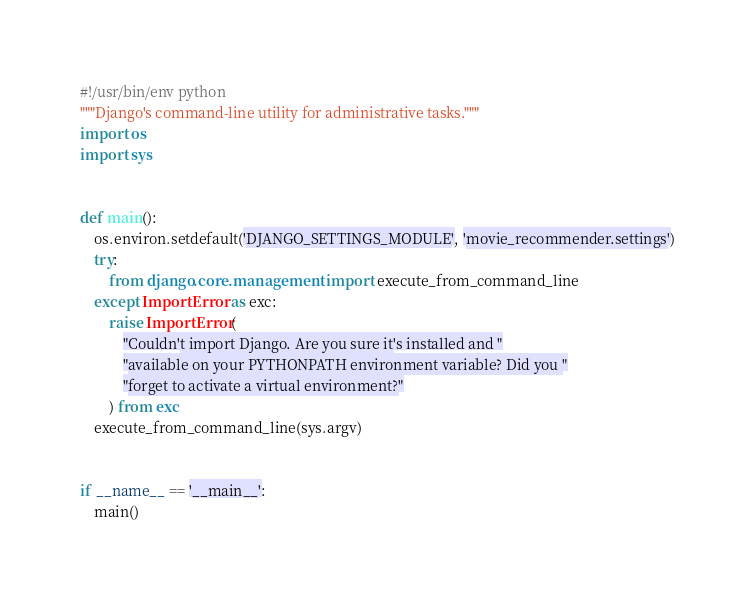<code> <loc_0><loc_0><loc_500><loc_500><_Python_>#!/usr/bin/env python
"""Django's command-line utility for administrative tasks."""
import os
import sys


def main():
    os.environ.setdefault('DJANGO_SETTINGS_MODULE', 'movie_recommender.settings')
    try:
        from django.core.management import execute_from_command_line
    except ImportError as exc:
        raise ImportError(
            "Couldn't import Django. Are you sure it's installed and "
            "available on your PYTHONPATH environment variable? Did you "
            "forget to activate a virtual environment?"
        ) from exc
    execute_from_command_line(sys.argv)


if __name__ == '__main__':
    main()
</code> 